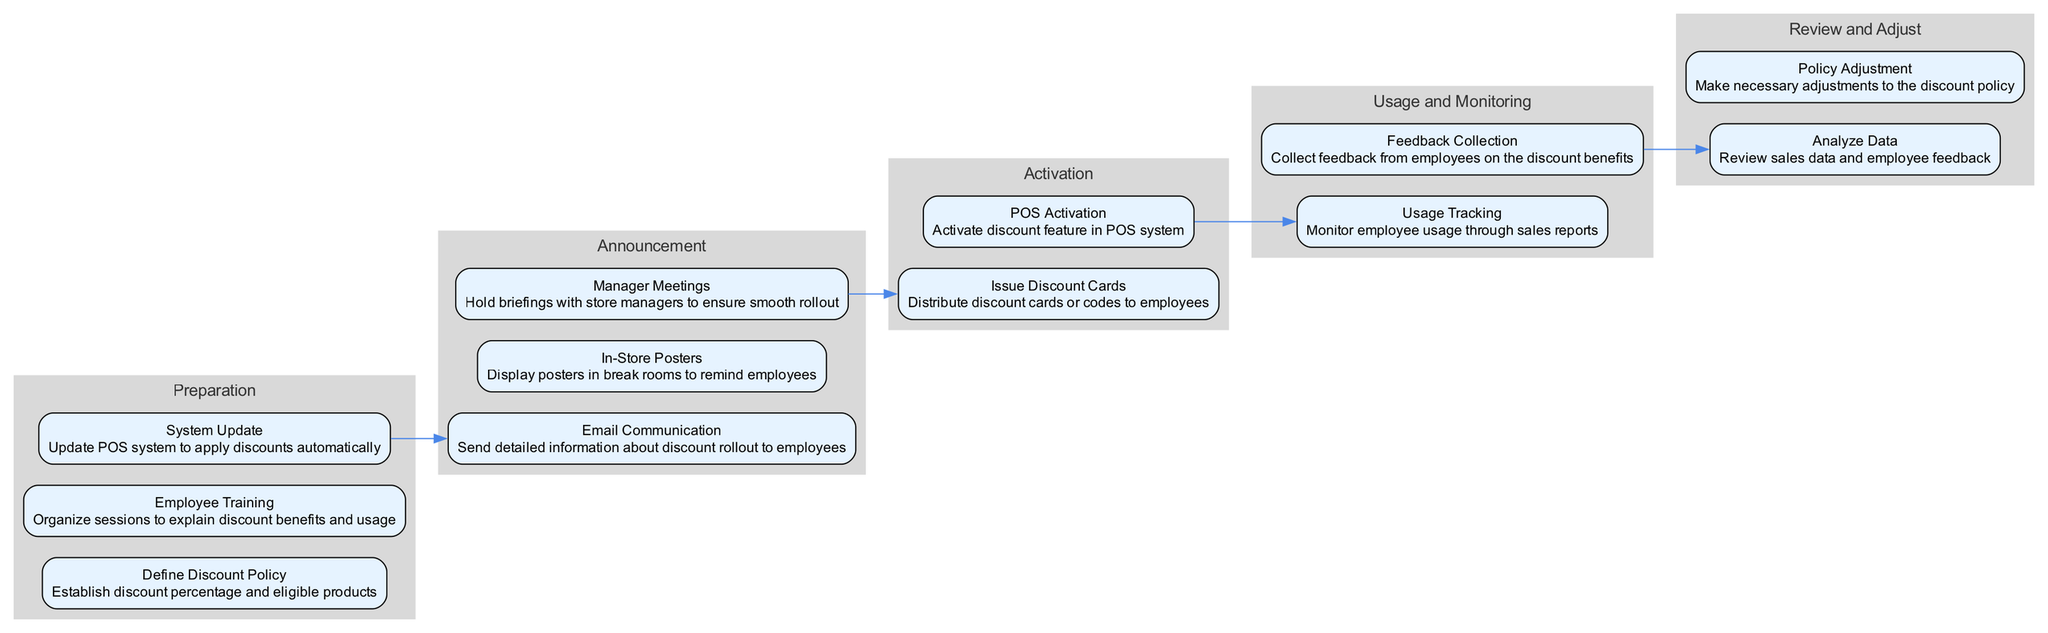What is the first stage in the pathway? The first stage in the pathway is "Preparation," as it is the initial step outlined in the sequential flow.
Answer: Preparation How many elements are in the "Announcement" stage? The "Announcement" stage consists of three elements: Email Communication, In-Store Posters, and Manager Meetings.
Answer: 3 What is the last action in the "Usage and Monitoring" stage? The last action in the "Usage and Monitoring" stage is "Feedback Collection," which is the final element in that stage.
Answer: Feedback Collection What connects "Employee Training" and "Email Communication"? "Employee Training" connects to "Email Communication" as part of the transition from the "Preparation" stage to the "Announcement" stage, indicating a flow through the pathway elements.
Answer: Transition Which stage includes "Policy Adjustment"? "Policy Adjustment" is included in the "Review and Adjust" stage, marking it as one of the final actions of the pathway to ensure the discount policy is effective.
Answer: Review and Adjust How many stages are there in total? There are five stages in total within the pathway, each representing a different phase of the employee discount rollout process.
Answer: 5 What is the transition from "POS Activation"? The transition from "POS Activation" leads to "Usage Tracking" in the "Usage and Monitoring" stage, indicating the next step after the POS system is activated.
Answer: Usage Tracking What key information is communicated through "In-Store Posters"? "In-Store Posters" serve to remind employees about the discount benefits, providing ongoing communication to encourage usage.
Answer: Reminder about discount benefits What is the purpose of the "System Update" element? The "System Update" element serves to ensure that the POS system is configured to apply the discounts automatically, facilitating seamless transactions for employees.
Answer: Apply discounts automatically 